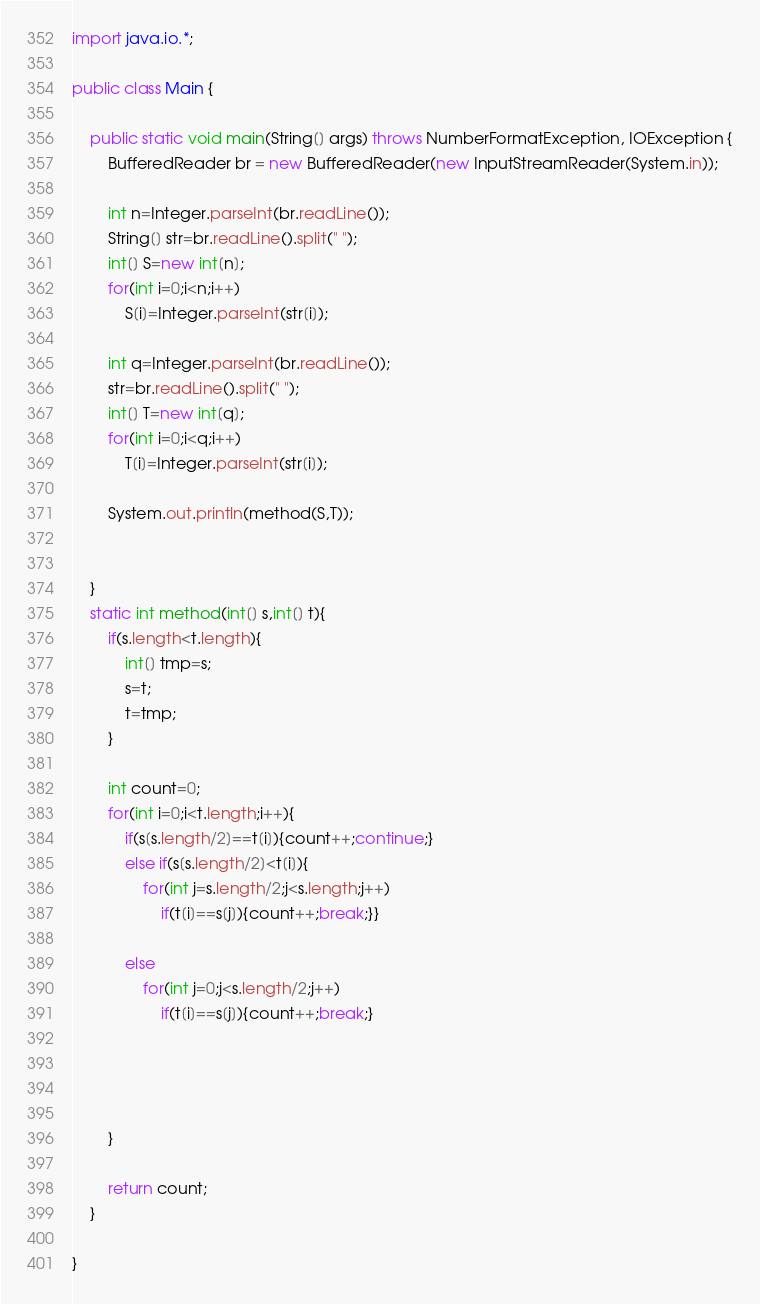<code> <loc_0><loc_0><loc_500><loc_500><_Java_>import java.io.*;

public class Main {

	public static void main(String[] args) throws NumberFormatException, IOException {
		BufferedReader br = new BufferedReader(new InputStreamReader(System.in));
		
		int n=Integer.parseInt(br.readLine());
        String[] str=br.readLine().split(" ");
        int[] S=new int[n];
        for(int i=0;i<n;i++)
            S[i]=Integer.parseInt(str[i]);
         
        int q=Integer.parseInt(br.readLine());
        str=br.readLine().split(" ");
        int[] T=new int[q];
        for(int i=0;i<q;i++)
            T[i]=Integer.parseInt(str[i]);
         
        System.out.println(method(S,T));
         
 
    }
    static int method(int[] s,int[] t){
        if(s.length<t.length){
            int[] tmp=s;
            s=t;
            t=tmp;
        }
        
        int count=0;
        for(int i=0;i<t.length;i++){
        	if(s[s.length/2]==t[i]){count++;continue;}
        	else if(s[s.length/2]<t[i]){
        		for(int j=s.length/2;j<s.length;j++)
        			if(t[i]==s[j]){count++;break;}}
        	
        	else
        		for(int j=0;j<s.length/2;j++)
        			if(t[i]==s[j]){count++;break;}
        	
        
                   
            
        }
         
        return count;
    }
 
}</code> 